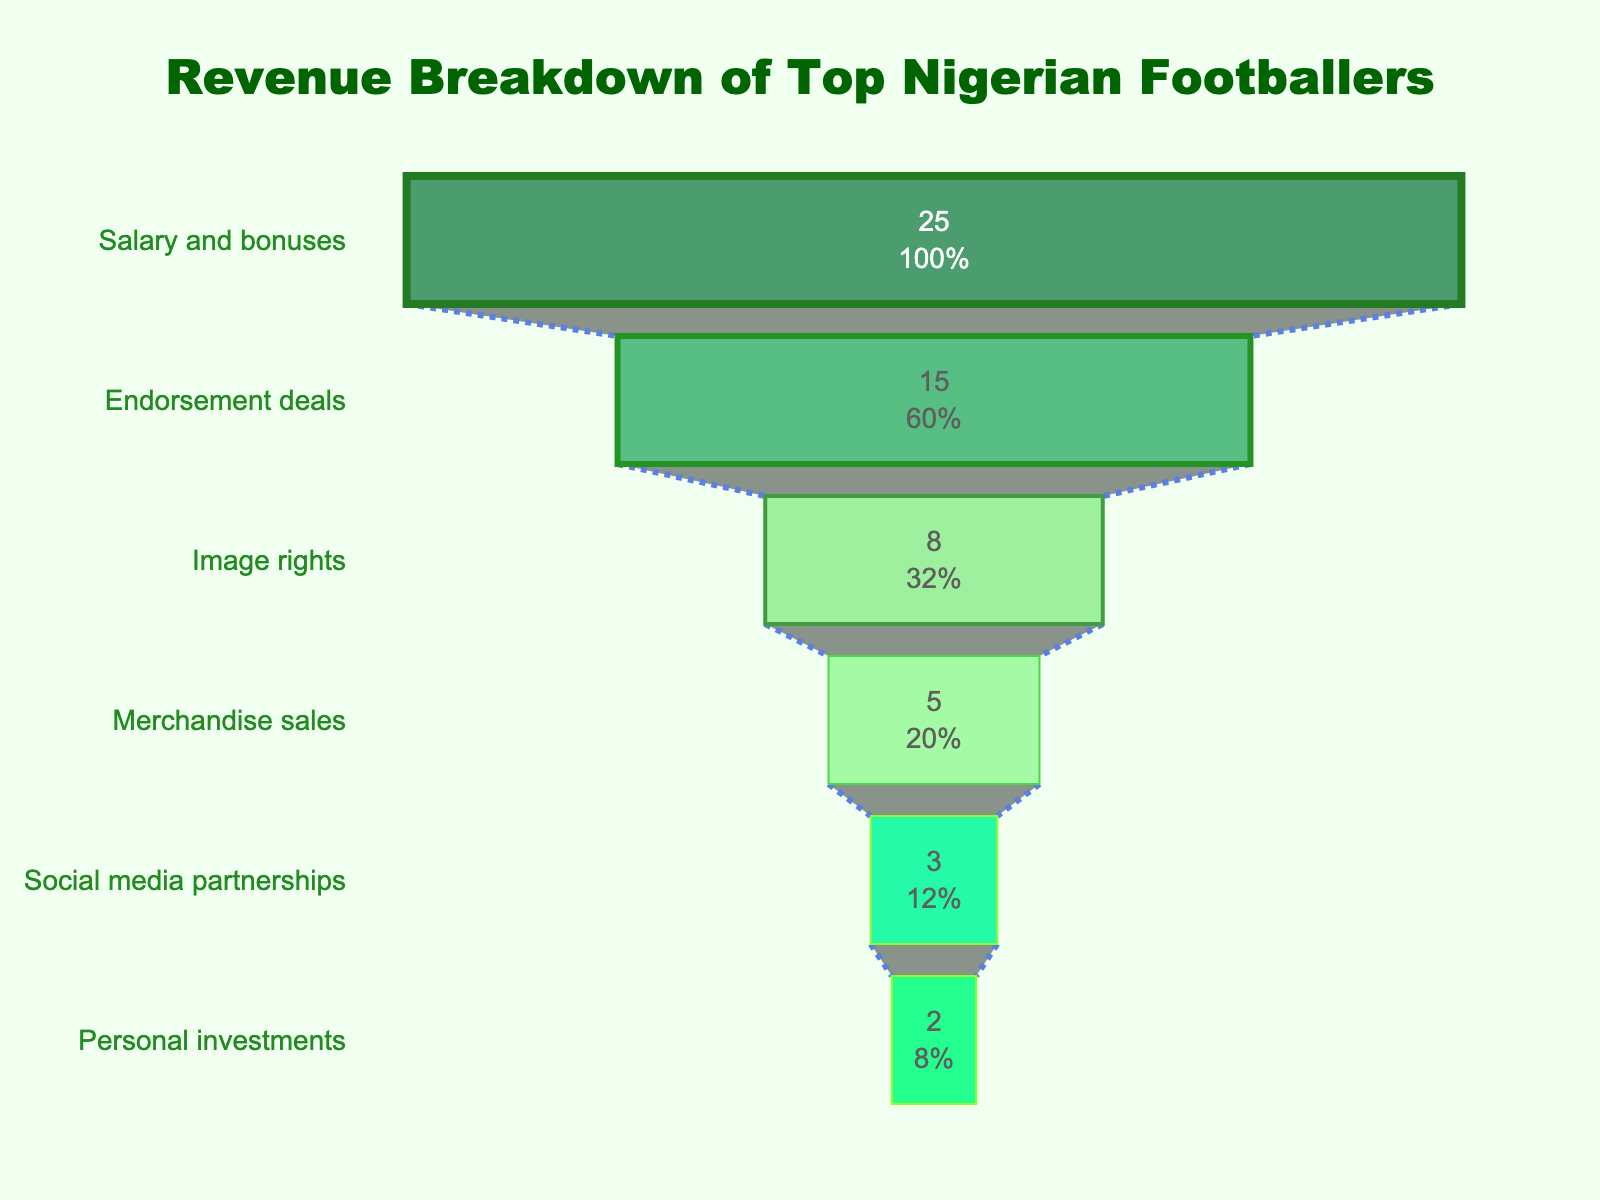Which income source has the highest revenue? Look at the funnel chart and see which income source has the widest segment at the top. The title of this section indicates it's the largest contributor to the total revenue.
Answer: Salary and bonuses What is the total revenue from social media partnerships and personal investments? Add the revenue from social media partnerships (3 million USD) and personal investments (2 million USD). 3 + 2 = 5
Answer: 5 million USD How does the revenue from merchandise sales compare to that from image rights? Check both revenue figures on the chart. Merchandise sales bring in 5 million USD, while image rights bring in 8 million USD.
Answer: Image rights have 3 million USD more revenue than merchandise sales What percentage of the total revenue comes from endorsement deals? Look at the percentage given inside the segment for endorsement deals (15 million USD). Divide it by the total revenue (58 million USD) and multiply by 100. (15 / 58) * 100 ≈ 25.9%
Answer: Approximately 25.9% Which income sources contribute less than 10% individually to the total revenue? Identify the segments in the funnel chart that have a percentage less than 10%. These are personal investments and social media partnerships.
Answer: Personal investments and social media partnerships How much higher is the revenue from image rights compared to social media partnerships? Subtract the revenue from social media partnerships (3 million USD) from image rights (8 million USD). 8 - 3 = 5
Answer: 5 million USD What is the combined revenue of the two largest income sources? Add the revenue from salary and bonuses (25 million USD) and endorsement deals (15 million USD). 25 + 15 = 40
Answer: 40 million USD What proportion of the total revenue is represented by image rights and merchandise sales together? Add the revenue from image rights (8 million USD) and merchandise sales (5 million USD). Divide by the total revenue (58 million USD) and multiply by 100. (8 + 5 / 58) * 100 ≈ 22.4%
Answer: Approximately 22.4% What is the difference in revenue between the largest and smallest income sources? Subtract the revenue from personal investments (2 million USD) from salary and bonuses (25 million USD). 25 - 2 = 23
Answer: 23 million USD Which income source lies in the middle when ordered by revenue? From top to bottom based on the funnel segments, the middle income source is image rights.
Answer: Image rights 